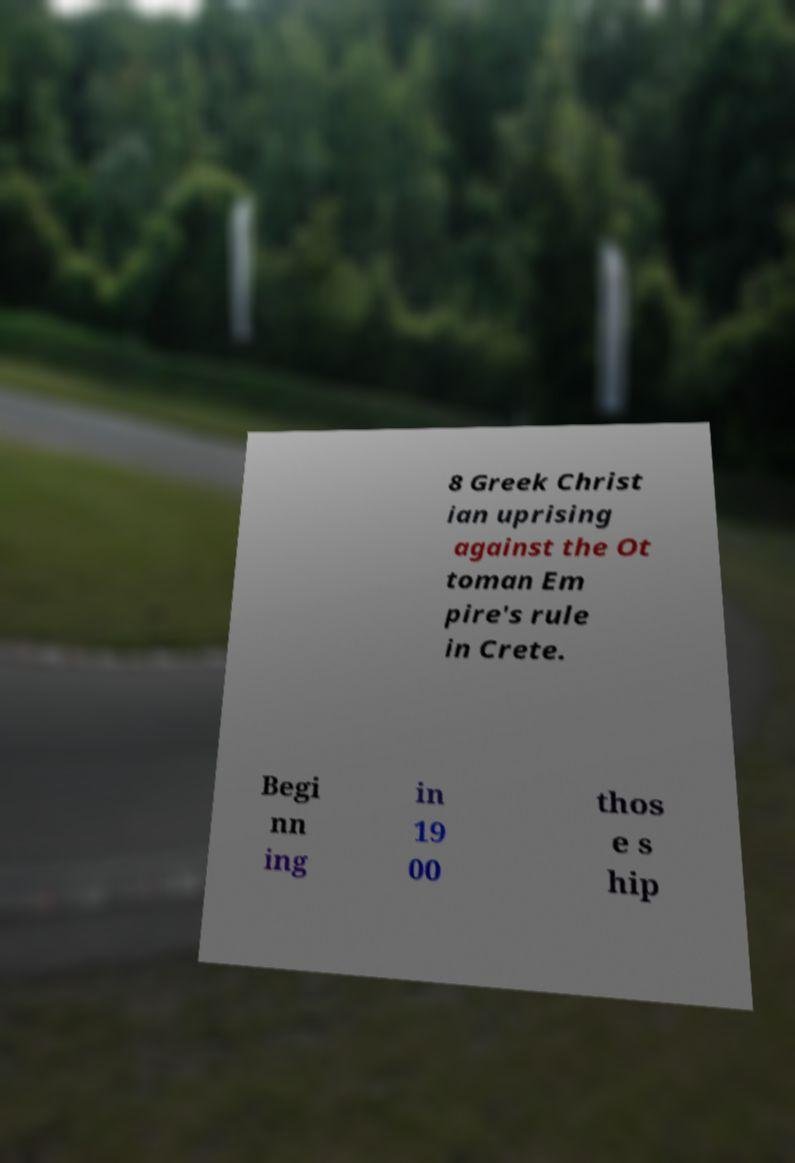I need the written content from this picture converted into text. Can you do that? 8 Greek Christ ian uprising against the Ot toman Em pire's rule in Crete. Begi nn ing in 19 00 thos e s hip 